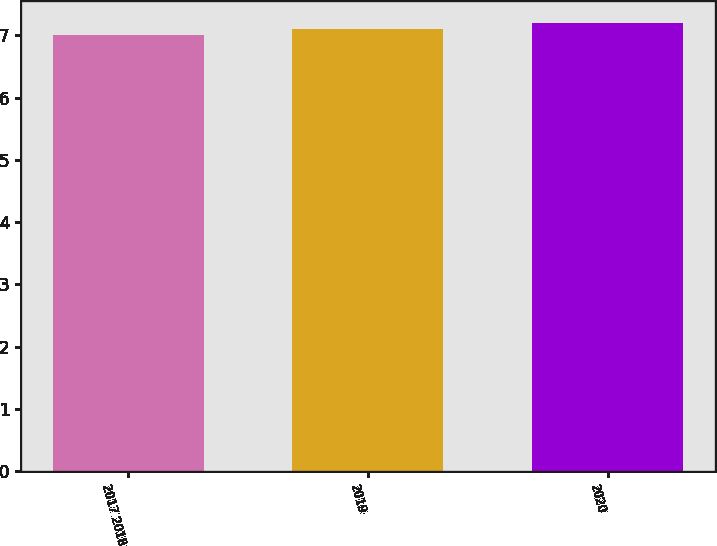Convert chart to OTSL. <chart><loc_0><loc_0><loc_500><loc_500><bar_chart><fcel>2017 2018<fcel>2019<fcel>2020<nl><fcel>7<fcel>7.1<fcel>7.2<nl></chart> 